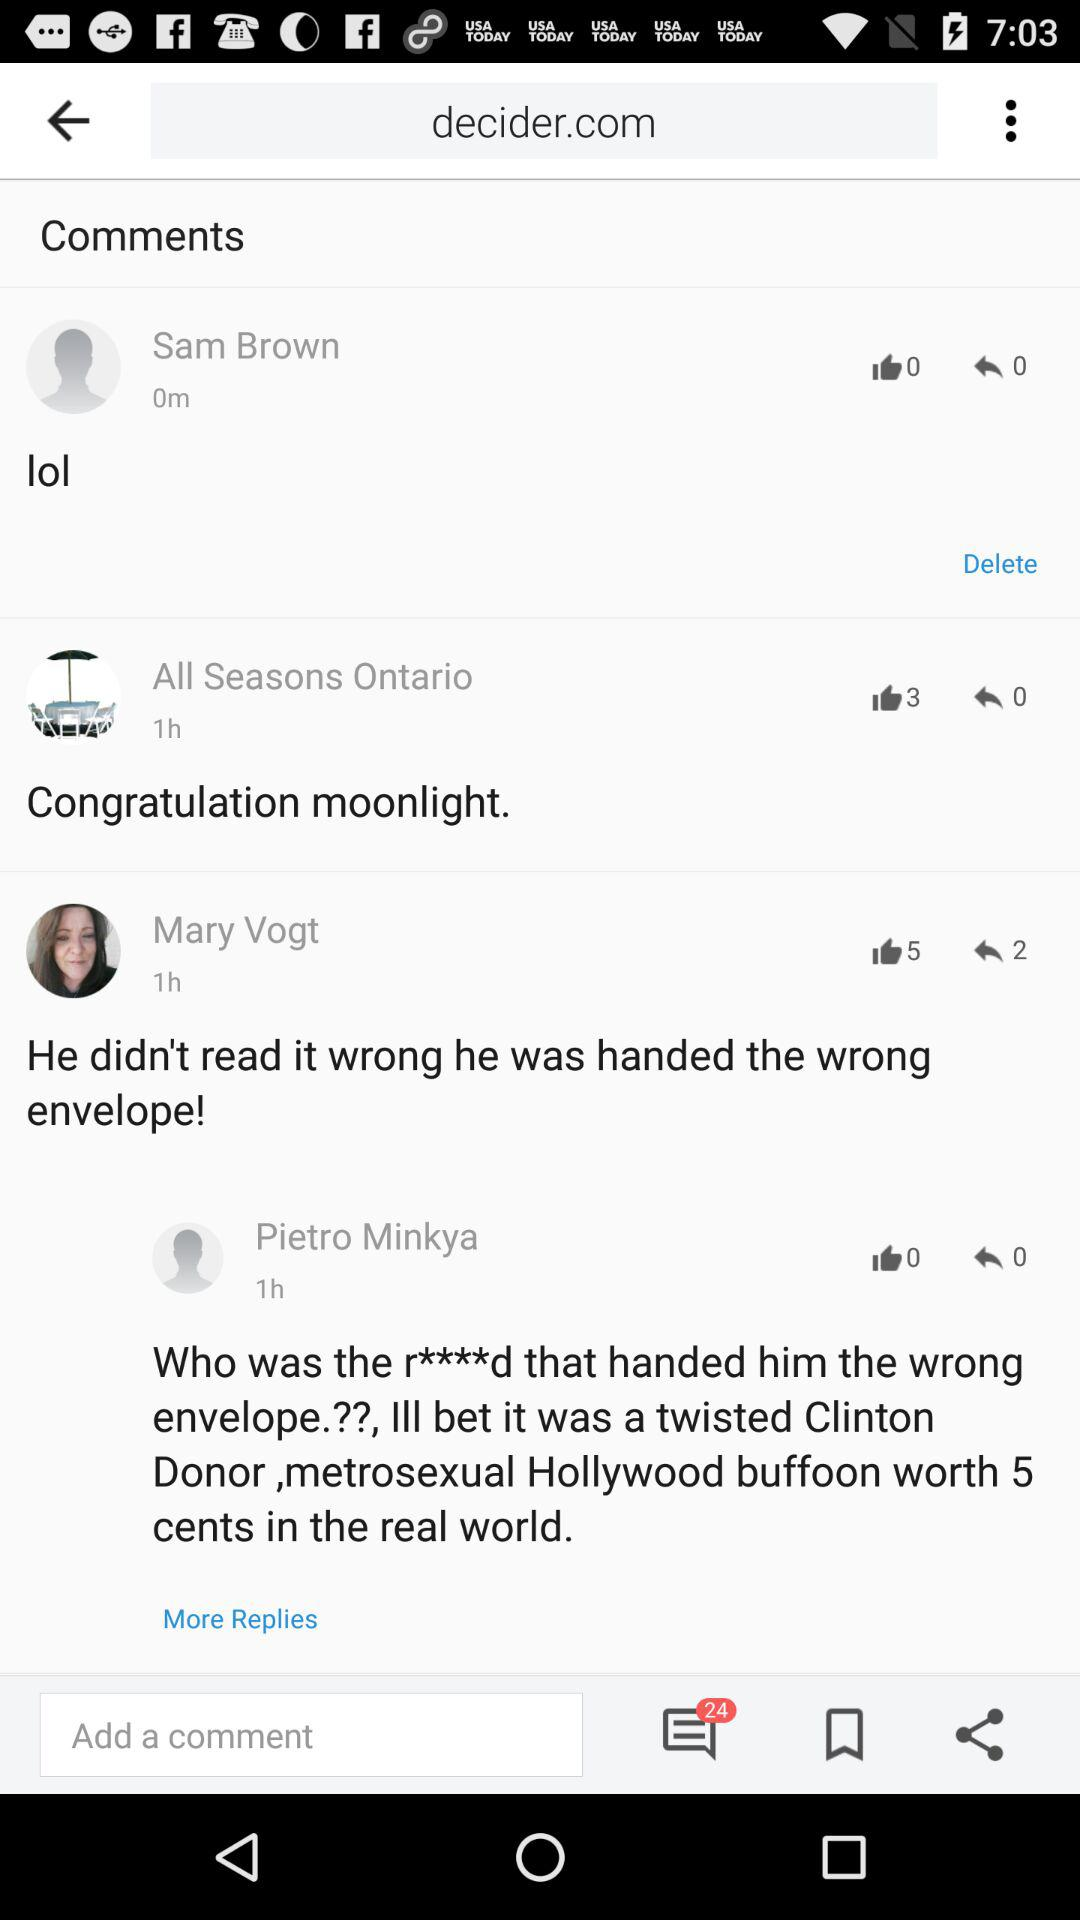How many minutes ago did Sam Brown comment on the post? Sam Brown commented on the post 0 minutes ago. 